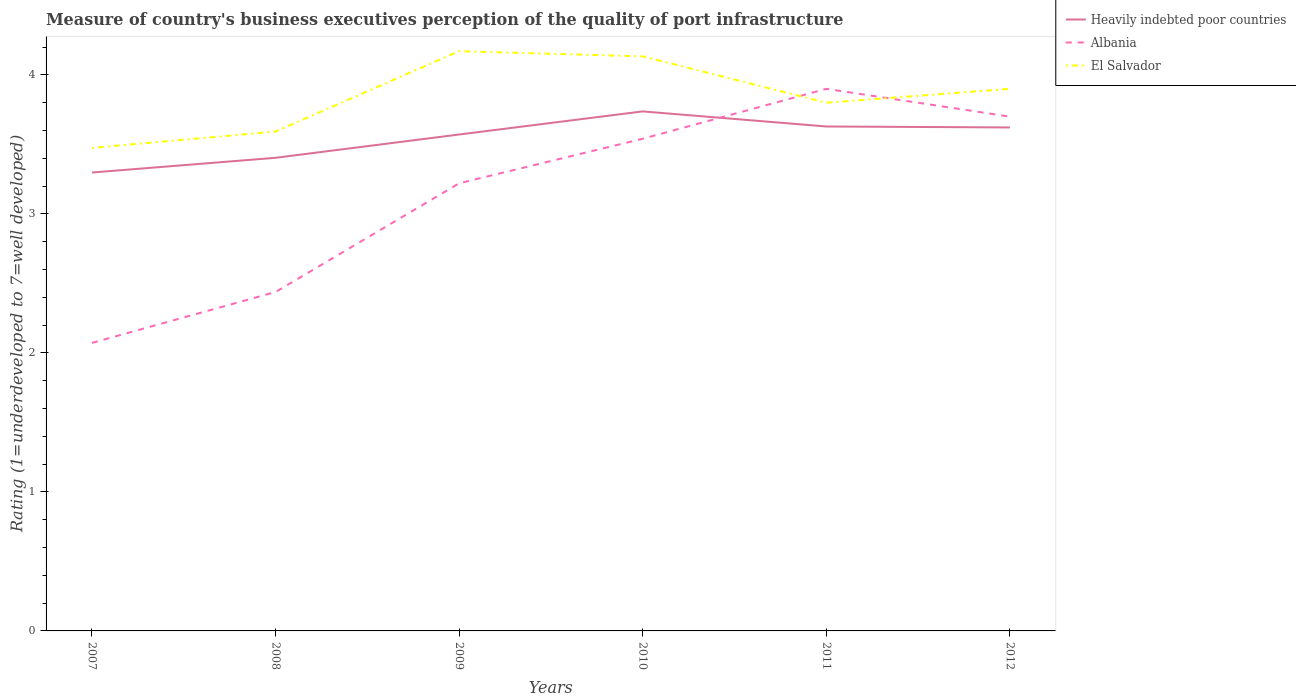Is the number of lines equal to the number of legend labels?
Give a very brief answer. Yes. Across all years, what is the maximum ratings of the quality of port infrastructure in Heavily indebted poor countries?
Offer a terse response. 3.3. In which year was the ratings of the quality of port infrastructure in El Salvador maximum?
Provide a short and direct response. 2007. What is the total ratings of the quality of port infrastructure in Albania in the graph?
Provide a short and direct response. -0.36. What is the difference between the highest and the second highest ratings of the quality of port infrastructure in Heavily indebted poor countries?
Give a very brief answer. 0.44. Is the ratings of the quality of port infrastructure in Albania strictly greater than the ratings of the quality of port infrastructure in Heavily indebted poor countries over the years?
Your response must be concise. No. How many lines are there?
Your answer should be very brief. 3. How many years are there in the graph?
Provide a short and direct response. 6. What is the difference between two consecutive major ticks on the Y-axis?
Your answer should be compact. 1. Are the values on the major ticks of Y-axis written in scientific E-notation?
Give a very brief answer. No. Does the graph contain any zero values?
Your answer should be very brief. No. Where does the legend appear in the graph?
Provide a succinct answer. Top right. How many legend labels are there?
Offer a very short reply. 3. What is the title of the graph?
Offer a terse response. Measure of country's business executives perception of the quality of port infrastructure. Does "Montenegro" appear as one of the legend labels in the graph?
Keep it short and to the point. No. What is the label or title of the X-axis?
Keep it short and to the point. Years. What is the label or title of the Y-axis?
Your answer should be compact. Rating (1=underdeveloped to 7=well developed). What is the Rating (1=underdeveloped to 7=well developed) of Heavily indebted poor countries in 2007?
Keep it short and to the point. 3.3. What is the Rating (1=underdeveloped to 7=well developed) in Albania in 2007?
Your answer should be compact. 2.07. What is the Rating (1=underdeveloped to 7=well developed) of El Salvador in 2007?
Offer a terse response. 3.48. What is the Rating (1=underdeveloped to 7=well developed) of Heavily indebted poor countries in 2008?
Provide a succinct answer. 3.4. What is the Rating (1=underdeveloped to 7=well developed) of Albania in 2008?
Your answer should be compact. 2.44. What is the Rating (1=underdeveloped to 7=well developed) of El Salvador in 2008?
Provide a succinct answer. 3.59. What is the Rating (1=underdeveloped to 7=well developed) in Heavily indebted poor countries in 2009?
Give a very brief answer. 3.57. What is the Rating (1=underdeveloped to 7=well developed) in Albania in 2009?
Your answer should be compact. 3.22. What is the Rating (1=underdeveloped to 7=well developed) of El Salvador in 2009?
Make the answer very short. 4.17. What is the Rating (1=underdeveloped to 7=well developed) of Heavily indebted poor countries in 2010?
Offer a terse response. 3.74. What is the Rating (1=underdeveloped to 7=well developed) of Albania in 2010?
Your answer should be very brief. 3.54. What is the Rating (1=underdeveloped to 7=well developed) of El Salvador in 2010?
Ensure brevity in your answer.  4.13. What is the Rating (1=underdeveloped to 7=well developed) in Heavily indebted poor countries in 2011?
Provide a succinct answer. 3.63. What is the Rating (1=underdeveloped to 7=well developed) of Albania in 2011?
Offer a very short reply. 3.9. What is the Rating (1=underdeveloped to 7=well developed) in El Salvador in 2011?
Ensure brevity in your answer.  3.8. What is the Rating (1=underdeveloped to 7=well developed) in Heavily indebted poor countries in 2012?
Give a very brief answer. 3.62. What is the Rating (1=underdeveloped to 7=well developed) in Albania in 2012?
Keep it short and to the point. 3.7. What is the Rating (1=underdeveloped to 7=well developed) of El Salvador in 2012?
Ensure brevity in your answer.  3.9. Across all years, what is the maximum Rating (1=underdeveloped to 7=well developed) of Heavily indebted poor countries?
Your response must be concise. 3.74. Across all years, what is the maximum Rating (1=underdeveloped to 7=well developed) in Albania?
Provide a short and direct response. 3.9. Across all years, what is the maximum Rating (1=underdeveloped to 7=well developed) of El Salvador?
Provide a short and direct response. 4.17. Across all years, what is the minimum Rating (1=underdeveloped to 7=well developed) in Heavily indebted poor countries?
Ensure brevity in your answer.  3.3. Across all years, what is the minimum Rating (1=underdeveloped to 7=well developed) of Albania?
Your response must be concise. 2.07. Across all years, what is the minimum Rating (1=underdeveloped to 7=well developed) in El Salvador?
Provide a succinct answer. 3.48. What is the total Rating (1=underdeveloped to 7=well developed) in Heavily indebted poor countries in the graph?
Keep it short and to the point. 21.26. What is the total Rating (1=underdeveloped to 7=well developed) of Albania in the graph?
Offer a very short reply. 18.87. What is the total Rating (1=underdeveloped to 7=well developed) of El Salvador in the graph?
Keep it short and to the point. 23.07. What is the difference between the Rating (1=underdeveloped to 7=well developed) in Heavily indebted poor countries in 2007 and that in 2008?
Offer a terse response. -0.11. What is the difference between the Rating (1=underdeveloped to 7=well developed) in Albania in 2007 and that in 2008?
Provide a succinct answer. -0.37. What is the difference between the Rating (1=underdeveloped to 7=well developed) in El Salvador in 2007 and that in 2008?
Keep it short and to the point. -0.12. What is the difference between the Rating (1=underdeveloped to 7=well developed) in Heavily indebted poor countries in 2007 and that in 2009?
Your answer should be compact. -0.27. What is the difference between the Rating (1=underdeveloped to 7=well developed) in Albania in 2007 and that in 2009?
Provide a succinct answer. -1.15. What is the difference between the Rating (1=underdeveloped to 7=well developed) of El Salvador in 2007 and that in 2009?
Provide a succinct answer. -0.7. What is the difference between the Rating (1=underdeveloped to 7=well developed) of Heavily indebted poor countries in 2007 and that in 2010?
Keep it short and to the point. -0.44. What is the difference between the Rating (1=underdeveloped to 7=well developed) in Albania in 2007 and that in 2010?
Your answer should be compact. -1.47. What is the difference between the Rating (1=underdeveloped to 7=well developed) of El Salvador in 2007 and that in 2010?
Give a very brief answer. -0.66. What is the difference between the Rating (1=underdeveloped to 7=well developed) of Heavily indebted poor countries in 2007 and that in 2011?
Your answer should be very brief. -0.33. What is the difference between the Rating (1=underdeveloped to 7=well developed) in Albania in 2007 and that in 2011?
Offer a very short reply. -1.83. What is the difference between the Rating (1=underdeveloped to 7=well developed) in El Salvador in 2007 and that in 2011?
Keep it short and to the point. -0.32. What is the difference between the Rating (1=underdeveloped to 7=well developed) in Heavily indebted poor countries in 2007 and that in 2012?
Provide a short and direct response. -0.32. What is the difference between the Rating (1=underdeveloped to 7=well developed) of Albania in 2007 and that in 2012?
Provide a succinct answer. -1.63. What is the difference between the Rating (1=underdeveloped to 7=well developed) in El Salvador in 2007 and that in 2012?
Your response must be concise. -0.42. What is the difference between the Rating (1=underdeveloped to 7=well developed) in Heavily indebted poor countries in 2008 and that in 2009?
Make the answer very short. -0.17. What is the difference between the Rating (1=underdeveloped to 7=well developed) of Albania in 2008 and that in 2009?
Your answer should be very brief. -0.78. What is the difference between the Rating (1=underdeveloped to 7=well developed) of El Salvador in 2008 and that in 2009?
Keep it short and to the point. -0.58. What is the difference between the Rating (1=underdeveloped to 7=well developed) in Heavily indebted poor countries in 2008 and that in 2010?
Your response must be concise. -0.33. What is the difference between the Rating (1=underdeveloped to 7=well developed) of Albania in 2008 and that in 2010?
Provide a succinct answer. -1.1. What is the difference between the Rating (1=underdeveloped to 7=well developed) of El Salvador in 2008 and that in 2010?
Your response must be concise. -0.54. What is the difference between the Rating (1=underdeveloped to 7=well developed) in Heavily indebted poor countries in 2008 and that in 2011?
Ensure brevity in your answer.  -0.23. What is the difference between the Rating (1=underdeveloped to 7=well developed) in Albania in 2008 and that in 2011?
Provide a short and direct response. -1.46. What is the difference between the Rating (1=underdeveloped to 7=well developed) of El Salvador in 2008 and that in 2011?
Offer a terse response. -0.21. What is the difference between the Rating (1=underdeveloped to 7=well developed) in Heavily indebted poor countries in 2008 and that in 2012?
Make the answer very short. -0.22. What is the difference between the Rating (1=underdeveloped to 7=well developed) of Albania in 2008 and that in 2012?
Offer a terse response. -1.26. What is the difference between the Rating (1=underdeveloped to 7=well developed) of El Salvador in 2008 and that in 2012?
Provide a short and direct response. -0.31. What is the difference between the Rating (1=underdeveloped to 7=well developed) of Heavily indebted poor countries in 2009 and that in 2010?
Ensure brevity in your answer.  -0.17. What is the difference between the Rating (1=underdeveloped to 7=well developed) of Albania in 2009 and that in 2010?
Make the answer very short. -0.32. What is the difference between the Rating (1=underdeveloped to 7=well developed) of El Salvador in 2009 and that in 2010?
Offer a terse response. 0.04. What is the difference between the Rating (1=underdeveloped to 7=well developed) of Heavily indebted poor countries in 2009 and that in 2011?
Your response must be concise. -0.06. What is the difference between the Rating (1=underdeveloped to 7=well developed) in Albania in 2009 and that in 2011?
Your response must be concise. -0.68. What is the difference between the Rating (1=underdeveloped to 7=well developed) of El Salvador in 2009 and that in 2011?
Your answer should be compact. 0.37. What is the difference between the Rating (1=underdeveloped to 7=well developed) in Heavily indebted poor countries in 2009 and that in 2012?
Your answer should be compact. -0.05. What is the difference between the Rating (1=underdeveloped to 7=well developed) in Albania in 2009 and that in 2012?
Offer a terse response. -0.48. What is the difference between the Rating (1=underdeveloped to 7=well developed) of El Salvador in 2009 and that in 2012?
Make the answer very short. 0.27. What is the difference between the Rating (1=underdeveloped to 7=well developed) in Heavily indebted poor countries in 2010 and that in 2011?
Your answer should be compact. 0.11. What is the difference between the Rating (1=underdeveloped to 7=well developed) in Albania in 2010 and that in 2011?
Give a very brief answer. -0.36. What is the difference between the Rating (1=underdeveloped to 7=well developed) in El Salvador in 2010 and that in 2011?
Provide a succinct answer. 0.33. What is the difference between the Rating (1=underdeveloped to 7=well developed) in Heavily indebted poor countries in 2010 and that in 2012?
Your response must be concise. 0.12. What is the difference between the Rating (1=underdeveloped to 7=well developed) of Albania in 2010 and that in 2012?
Give a very brief answer. -0.16. What is the difference between the Rating (1=underdeveloped to 7=well developed) of El Salvador in 2010 and that in 2012?
Your response must be concise. 0.23. What is the difference between the Rating (1=underdeveloped to 7=well developed) in Heavily indebted poor countries in 2011 and that in 2012?
Make the answer very short. 0.01. What is the difference between the Rating (1=underdeveloped to 7=well developed) in Heavily indebted poor countries in 2007 and the Rating (1=underdeveloped to 7=well developed) in Albania in 2008?
Offer a very short reply. 0.86. What is the difference between the Rating (1=underdeveloped to 7=well developed) of Heavily indebted poor countries in 2007 and the Rating (1=underdeveloped to 7=well developed) of El Salvador in 2008?
Your answer should be compact. -0.29. What is the difference between the Rating (1=underdeveloped to 7=well developed) of Albania in 2007 and the Rating (1=underdeveloped to 7=well developed) of El Salvador in 2008?
Offer a very short reply. -1.52. What is the difference between the Rating (1=underdeveloped to 7=well developed) in Heavily indebted poor countries in 2007 and the Rating (1=underdeveloped to 7=well developed) in Albania in 2009?
Make the answer very short. 0.08. What is the difference between the Rating (1=underdeveloped to 7=well developed) in Heavily indebted poor countries in 2007 and the Rating (1=underdeveloped to 7=well developed) in El Salvador in 2009?
Give a very brief answer. -0.87. What is the difference between the Rating (1=underdeveloped to 7=well developed) in Albania in 2007 and the Rating (1=underdeveloped to 7=well developed) in El Salvador in 2009?
Keep it short and to the point. -2.1. What is the difference between the Rating (1=underdeveloped to 7=well developed) of Heavily indebted poor countries in 2007 and the Rating (1=underdeveloped to 7=well developed) of Albania in 2010?
Your answer should be compact. -0.24. What is the difference between the Rating (1=underdeveloped to 7=well developed) in Heavily indebted poor countries in 2007 and the Rating (1=underdeveloped to 7=well developed) in El Salvador in 2010?
Offer a terse response. -0.84. What is the difference between the Rating (1=underdeveloped to 7=well developed) in Albania in 2007 and the Rating (1=underdeveloped to 7=well developed) in El Salvador in 2010?
Provide a succinct answer. -2.06. What is the difference between the Rating (1=underdeveloped to 7=well developed) in Heavily indebted poor countries in 2007 and the Rating (1=underdeveloped to 7=well developed) in Albania in 2011?
Give a very brief answer. -0.6. What is the difference between the Rating (1=underdeveloped to 7=well developed) in Heavily indebted poor countries in 2007 and the Rating (1=underdeveloped to 7=well developed) in El Salvador in 2011?
Make the answer very short. -0.5. What is the difference between the Rating (1=underdeveloped to 7=well developed) in Albania in 2007 and the Rating (1=underdeveloped to 7=well developed) in El Salvador in 2011?
Offer a very short reply. -1.73. What is the difference between the Rating (1=underdeveloped to 7=well developed) in Heavily indebted poor countries in 2007 and the Rating (1=underdeveloped to 7=well developed) in Albania in 2012?
Your answer should be very brief. -0.4. What is the difference between the Rating (1=underdeveloped to 7=well developed) in Heavily indebted poor countries in 2007 and the Rating (1=underdeveloped to 7=well developed) in El Salvador in 2012?
Your answer should be compact. -0.6. What is the difference between the Rating (1=underdeveloped to 7=well developed) in Albania in 2007 and the Rating (1=underdeveloped to 7=well developed) in El Salvador in 2012?
Make the answer very short. -1.83. What is the difference between the Rating (1=underdeveloped to 7=well developed) in Heavily indebted poor countries in 2008 and the Rating (1=underdeveloped to 7=well developed) in Albania in 2009?
Provide a succinct answer. 0.18. What is the difference between the Rating (1=underdeveloped to 7=well developed) in Heavily indebted poor countries in 2008 and the Rating (1=underdeveloped to 7=well developed) in El Salvador in 2009?
Ensure brevity in your answer.  -0.77. What is the difference between the Rating (1=underdeveloped to 7=well developed) in Albania in 2008 and the Rating (1=underdeveloped to 7=well developed) in El Salvador in 2009?
Your answer should be compact. -1.73. What is the difference between the Rating (1=underdeveloped to 7=well developed) of Heavily indebted poor countries in 2008 and the Rating (1=underdeveloped to 7=well developed) of Albania in 2010?
Make the answer very short. -0.14. What is the difference between the Rating (1=underdeveloped to 7=well developed) of Heavily indebted poor countries in 2008 and the Rating (1=underdeveloped to 7=well developed) of El Salvador in 2010?
Offer a very short reply. -0.73. What is the difference between the Rating (1=underdeveloped to 7=well developed) in Albania in 2008 and the Rating (1=underdeveloped to 7=well developed) in El Salvador in 2010?
Offer a terse response. -1.7. What is the difference between the Rating (1=underdeveloped to 7=well developed) in Heavily indebted poor countries in 2008 and the Rating (1=underdeveloped to 7=well developed) in Albania in 2011?
Make the answer very short. -0.5. What is the difference between the Rating (1=underdeveloped to 7=well developed) of Heavily indebted poor countries in 2008 and the Rating (1=underdeveloped to 7=well developed) of El Salvador in 2011?
Your answer should be compact. -0.4. What is the difference between the Rating (1=underdeveloped to 7=well developed) in Albania in 2008 and the Rating (1=underdeveloped to 7=well developed) in El Salvador in 2011?
Your response must be concise. -1.36. What is the difference between the Rating (1=underdeveloped to 7=well developed) of Heavily indebted poor countries in 2008 and the Rating (1=underdeveloped to 7=well developed) of Albania in 2012?
Provide a short and direct response. -0.3. What is the difference between the Rating (1=underdeveloped to 7=well developed) in Heavily indebted poor countries in 2008 and the Rating (1=underdeveloped to 7=well developed) in El Salvador in 2012?
Your answer should be very brief. -0.5. What is the difference between the Rating (1=underdeveloped to 7=well developed) of Albania in 2008 and the Rating (1=underdeveloped to 7=well developed) of El Salvador in 2012?
Make the answer very short. -1.46. What is the difference between the Rating (1=underdeveloped to 7=well developed) in Heavily indebted poor countries in 2009 and the Rating (1=underdeveloped to 7=well developed) in Albania in 2010?
Offer a terse response. 0.03. What is the difference between the Rating (1=underdeveloped to 7=well developed) of Heavily indebted poor countries in 2009 and the Rating (1=underdeveloped to 7=well developed) of El Salvador in 2010?
Make the answer very short. -0.56. What is the difference between the Rating (1=underdeveloped to 7=well developed) of Albania in 2009 and the Rating (1=underdeveloped to 7=well developed) of El Salvador in 2010?
Give a very brief answer. -0.91. What is the difference between the Rating (1=underdeveloped to 7=well developed) of Heavily indebted poor countries in 2009 and the Rating (1=underdeveloped to 7=well developed) of Albania in 2011?
Your response must be concise. -0.33. What is the difference between the Rating (1=underdeveloped to 7=well developed) of Heavily indebted poor countries in 2009 and the Rating (1=underdeveloped to 7=well developed) of El Salvador in 2011?
Provide a succinct answer. -0.23. What is the difference between the Rating (1=underdeveloped to 7=well developed) of Albania in 2009 and the Rating (1=underdeveloped to 7=well developed) of El Salvador in 2011?
Keep it short and to the point. -0.58. What is the difference between the Rating (1=underdeveloped to 7=well developed) of Heavily indebted poor countries in 2009 and the Rating (1=underdeveloped to 7=well developed) of Albania in 2012?
Provide a short and direct response. -0.13. What is the difference between the Rating (1=underdeveloped to 7=well developed) of Heavily indebted poor countries in 2009 and the Rating (1=underdeveloped to 7=well developed) of El Salvador in 2012?
Provide a short and direct response. -0.33. What is the difference between the Rating (1=underdeveloped to 7=well developed) in Albania in 2009 and the Rating (1=underdeveloped to 7=well developed) in El Salvador in 2012?
Your answer should be compact. -0.68. What is the difference between the Rating (1=underdeveloped to 7=well developed) of Heavily indebted poor countries in 2010 and the Rating (1=underdeveloped to 7=well developed) of Albania in 2011?
Provide a succinct answer. -0.16. What is the difference between the Rating (1=underdeveloped to 7=well developed) of Heavily indebted poor countries in 2010 and the Rating (1=underdeveloped to 7=well developed) of El Salvador in 2011?
Provide a succinct answer. -0.06. What is the difference between the Rating (1=underdeveloped to 7=well developed) of Albania in 2010 and the Rating (1=underdeveloped to 7=well developed) of El Salvador in 2011?
Offer a terse response. -0.26. What is the difference between the Rating (1=underdeveloped to 7=well developed) of Heavily indebted poor countries in 2010 and the Rating (1=underdeveloped to 7=well developed) of Albania in 2012?
Keep it short and to the point. 0.04. What is the difference between the Rating (1=underdeveloped to 7=well developed) in Heavily indebted poor countries in 2010 and the Rating (1=underdeveloped to 7=well developed) in El Salvador in 2012?
Give a very brief answer. -0.16. What is the difference between the Rating (1=underdeveloped to 7=well developed) of Albania in 2010 and the Rating (1=underdeveloped to 7=well developed) of El Salvador in 2012?
Provide a short and direct response. -0.36. What is the difference between the Rating (1=underdeveloped to 7=well developed) of Heavily indebted poor countries in 2011 and the Rating (1=underdeveloped to 7=well developed) of Albania in 2012?
Keep it short and to the point. -0.07. What is the difference between the Rating (1=underdeveloped to 7=well developed) in Heavily indebted poor countries in 2011 and the Rating (1=underdeveloped to 7=well developed) in El Salvador in 2012?
Your answer should be very brief. -0.27. What is the average Rating (1=underdeveloped to 7=well developed) of Heavily indebted poor countries per year?
Make the answer very short. 3.54. What is the average Rating (1=underdeveloped to 7=well developed) of Albania per year?
Provide a short and direct response. 3.15. What is the average Rating (1=underdeveloped to 7=well developed) of El Salvador per year?
Keep it short and to the point. 3.85. In the year 2007, what is the difference between the Rating (1=underdeveloped to 7=well developed) of Heavily indebted poor countries and Rating (1=underdeveloped to 7=well developed) of Albania?
Make the answer very short. 1.23. In the year 2007, what is the difference between the Rating (1=underdeveloped to 7=well developed) of Heavily indebted poor countries and Rating (1=underdeveloped to 7=well developed) of El Salvador?
Your answer should be very brief. -0.18. In the year 2007, what is the difference between the Rating (1=underdeveloped to 7=well developed) in Albania and Rating (1=underdeveloped to 7=well developed) in El Salvador?
Provide a short and direct response. -1.4. In the year 2008, what is the difference between the Rating (1=underdeveloped to 7=well developed) in Heavily indebted poor countries and Rating (1=underdeveloped to 7=well developed) in Albania?
Make the answer very short. 0.97. In the year 2008, what is the difference between the Rating (1=underdeveloped to 7=well developed) of Heavily indebted poor countries and Rating (1=underdeveloped to 7=well developed) of El Salvador?
Offer a terse response. -0.19. In the year 2008, what is the difference between the Rating (1=underdeveloped to 7=well developed) of Albania and Rating (1=underdeveloped to 7=well developed) of El Salvador?
Give a very brief answer. -1.15. In the year 2009, what is the difference between the Rating (1=underdeveloped to 7=well developed) of Heavily indebted poor countries and Rating (1=underdeveloped to 7=well developed) of Albania?
Provide a succinct answer. 0.35. In the year 2009, what is the difference between the Rating (1=underdeveloped to 7=well developed) in Heavily indebted poor countries and Rating (1=underdeveloped to 7=well developed) in El Salvador?
Your answer should be very brief. -0.6. In the year 2009, what is the difference between the Rating (1=underdeveloped to 7=well developed) of Albania and Rating (1=underdeveloped to 7=well developed) of El Salvador?
Keep it short and to the point. -0.95. In the year 2010, what is the difference between the Rating (1=underdeveloped to 7=well developed) of Heavily indebted poor countries and Rating (1=underdeveloped to 7=well developed) of Albania?
Keep it short and to the point. 0.2. In the year 2010, what is the difference between the Rating (1=underdeveloped to 7=well developed) of Heavily indebted poor countries and Rating (1=underdeveloped to 7=well developed) of El Salvador?
Provide a succinct answer. -0.4. In the year 2010, what is the difference between the Rating (1=underdeveloped to 7=well developed) in Albania and Rating (1=underdeveloped to 7=well developed) in El Salvador?
Your response must be concise. -0.59. In the year 2011, what is the difference between the Rating (1=underdeveloped to 7=well developed) of Heavily indebted poor countries and Rating (1=underdeveloped to 7=well developed) of Albania?
Make the answer very short. -0.27. In the year 2011, what is the difference between the Rating (1=underdeveloped to 7=well developed) of Heavily indebted poor countries and Rating (1=underdeveloped to 7=well developed) of El Salvador?
Your answer should be compact. -0.17. In the year 2012, what is the difference between the Rating (1=underdeveloped to 7=well developed) in Heavily indebted poor countries and Rating (1=underdeveloped to 7=well developed) in Albania?
Keep it short and to the point. -0.08. In the year 2012, what is the difference between the Rating (1=underdeveloped to 7=well developed) of Heavily indebted poor countries and Rating (1=underdeveloped to 7=well developed) of El Salvador?
Provide a short and direct response. -0.28. What is the ratio of the Rating (1=underdeveloped to 7=well developed) of Heavily indebted poor countries in 2007 to that in 2008?
Your answer should be compact. 0.97. What is the ratio of the Rating (1=underdeveloped to 7=well developed) in Albania in 2007 to that in 2008?
Give a very brief answer. 0.85. What is the ratio of the Rating (1=underdeveloped to 7=well developed) in El Salvador in 2007 to that in 2008?
Give a very brief answer. 0.97. What is the ratio of the Rating (1=underdeveloped to 7=well developed) of Heavily indebted poor countries in 2007 to that in 2009?
Offer a terse response. 0.92. What is the ratio of the Rating (1=underdeveloped to 7=well developed) in Albania in 2007 to that in 2009?
Your response must be concise. 0.64. What is the ratio of the Rating (1=underdeveloped to 7=well developed) in El Salvador in 2007 to that in 2009?
Offer a terse response. 0.83. What is the ratio of the Rating (1=underdeveloped to 7=well developed) of Heavily indebted poor countries in 2007 to that in 2010?
Provide a succinct answer. 0.88. What is the ratio of the Rating (1=underdeveloped to 7=well developed) of Albania in 2007 to that in 2010?
Ensure brevity in your answer.  0.59. What is the ratio of the Rating (1=underdeveloped to 7=well developed) in El Salvador in 2007 to that in 2010?
Ensure brevity in your answer.  0.84. What is the ratio of the Rating (1=underdeveloped to 7=well developed) in Heavily indebted poor countries in 2007 to that in 2011?
Provide a succinct answer. 0.91. What is the ratio of the Rating (1=underdeveloped to 7=well developed) in Albania in 2007 to that in 2011?
Provide a short and direct response. 0.53. What is the ratio of the Rating (1=underdeveloped to 7=well developed) of El Salvador in 2007 to that in 2011?
Your response must be concise. 0.91. What is the ratio of the Rating (1=underdeveloped to 7=well developed) in Heavily indebted poor countries in 2007 to that in 2012?
Make the answer very short. 0.91. What is the ratio of the Rating (1=underdeveloped to 7=well developed) of Albania in 2007 to that in 2012?
Ensure brevity in your answer.  0.56. What is the ratio of the Rating (1=underdeveloped to 7=well developed) of El Salvador in 2007 to that in 2012?
Your answer should be very brief. 0.89. What is the ratio of the Rating (1=underdeveloped to 7=well developed) of Heavily indebted poor countries in 2008 to that in 2009?
Give a very brief answer. 0.95. What is the ratio of the Rating (1=underdeveloped to 7=well developed) of Albania in 2008 to that in 2009?
Make the answer very short. 0.76. What is the ratio of the Rating (1=underdeveloped to 7=well developed) of El Salvador in 2008 to that in 2009?
Your response must be concise. 0.86. What is the ratio of the Rating (1=underdeveloped to 7=well developed) of Heavily indebted poor countries in 2008 to that in 2010?
Make the answer very short. 0.91. What is the ratio of the Rating (1=underdeveloped to 7=well developed) of Albania in 2008 to that in 2010?
Your answer should be very brief. 0.69. What is the ratio of the Rating (1=underdeveloped to 7=well developed) of El Salvador in 2008 to that in 2010?
Your response must be concise. 0.87. What is the ratio of the Rating (1=underdeveloped to 7=well developed) of Heavily indebted poor countries in 2008 to that in 2011?
Keep it short and to the point. 0.94. What is the ratio of the Rating (1=underdeveloped to 7=well developed) of Albania in 2008 to that in 2011?
Offer a terse response. 0.63. What is the ratio of the Rating (1=underdeveloped to 7=well developed) of El Salvador in 2008 to that in 2011?
Keep it short and to the point. 0.95. What is the ratio of the Rating (1=underdeveloped to 7=well developed) in Heavily indebted poor countries in 2008 to that in 2012?
Give a very brief answer. 0.94. What is the ratio of the Rating (1=underdeveloped to 7=well developed) in Albania in 2008 to that in 2012?
Offer a terse response. 0.66. What is the ratio of the Rating (1=underdeveloped to 7=well developed) in El Salvador in 2008 to that in 2012?
Make the answer very short. 0.92. What is the ratio of the Rating (1=underdeveloped to 7=well developed) in Heavily indebted poor countries in 2009 to that in 2010?
Provide a short and direct response. 0.96. What is the ratio of the Rating (1=underdeveloped to 7=well developed) in Albania in 2009 to that in 2010?
Offer a very short reply. 0.91. What is the ratio of the Rating (1=underdeveloped to 7=well developed) in El Salvador in 2009 to that in 2010?
Make the answer very short. 1.01. What is the ratio of the Rating (1=underdeveloped to 7=well developed) of Heavily indebted poor countries in 2009 to that in 2011?
Give a very brief answer. 0.98. What is the ratio of the Rating (1=underdeveloped to 7=well developed) of Albania in 2009 to that in 2011?
Your answer should be very brief. 0.83. What is the ratio of the Rating (1=underdeveloped to 7=well developed) of El Salvador in 2009 to that in 2011?
Offer a terse response. 1.1. What is the ratio of the Rating (1=underdeveloped to 7=well developed) in Albania in 2009 to that in 2012?
Keep it short and to the point. 0.87. What is the ratio of the Rating (1=underdeveloped to 7=well developed) in El Salvador in 2009 to that in 2012?
Give a very brief answer. 1.07. What is the ratio of the Rating (1=underdeveloped to 7=well developed) of Heavily indebted poor countries in 2010 to that in 2011?
Your answer should be compact. 1.03. What is the ratio of the Rating (1=underdeveloped to 7=well developed) of Albania in 2010 to that in 2011?
Your answer should be very brief. 0.91. What is the ratio of the Rating (1=underdeveloped to 7=well developed) of El Salvador in 2010 to that in 2011?
Your answer should be very brief. 1.09. What is the ratio of the Rating (1=underdeveloped to 7=well developed) of Heavily indebted poor countries in 2010 to that in 2012?
Give a very brief answer. 1.03. What is the ratio of the Rating (1=underdeveloped to 7=well developed) of El Salvador in 2010 to that in 2012?
Provide a succinct answer. 1.06. What is the ratio of the Rating (1=underdeveloped to 7=well developed) of Heavily indebted poor countries in 2011 to that in 2012?
Ensure brevity in your answer.  1. What is the ratio of the Rating (1=underdeveloped to 7=well developed) of Albania in 2011 to that in 2012?
Your response must be concise. 1.05. What is the ratio of the Rating (1=underdeveloped to 7=well developed) in El Salvador in 2011 to that in 2012?
Keep it short and to the point. 0.97. What is the difference between the highest and the second highest Rating (1=underdeveloped to 7=well developed) of Heavily indebted poor countries?
Provide a short and direct response. 0.11. What is the difference between the highest and the second highest Rating (1=underdeveloped to 7=well developed) of Albania?
Ensure brevity in your answer.  0.2. What is the difference between the highest and the second highest Rating (1=underdeveloped to 7=well developed) in El Salvador?
Your answer should be very brief. 0.04. What is the difference between the highest and the lowest Rating (1=underdeveloped to 7=well developed) of Heavily indebted poor countries?
Give a very brief answer. 0.44. What is the difference between the highest and the lowest Rating (1=underdeveloped to 7=well developed) in Albania?
Provide a succinct answer. 1.83. What is the difference between the highest and the lowest Rating (1=underdeveloped to 7=well developed) in El Salvador?
Offer a terse response. 0.7. 